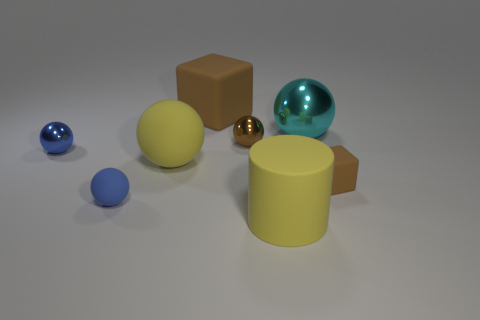There is a brown matte thing that is the same size as the cyan metallic thing; what is its shape?
Provide a succinct answer. Cube. Are there any other things that have the same shape as the small blue metal object?
Your response must be concise. Yes. There is a block behind the small metallic thing that is on the right side of the tiny blue rubber sphere; is there a brown matte block left of it?
Make the answer very short. No. Is the number of matte balls that are behind the tiny blue rubber object greater than the number of big yellow cylinders that are to the left of the large brown thing?
Offer a terse response. Yes. There is a yellow ball that is the same size as the matte cylinder; what is it made of?
Your answer should be compact. Rubber. What number of large things are cyan cylinders or brown spheres?
Offer a terse response. 0. Do the large brown object and the small blue metal thing have the same shape?
Your response must be concise. No. How many objects are both right of the blue rubber thing and behind the blue rubber thing?
Your answer should be very brief. 5. Are there any other things that are the same color as the large metal sphere?
Offer a very short reply. No. There is a small blue object that is made of the same material as the large cyan thing; what shape is it?
Provide a short and direct response. Sphere. 